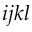<formula> <loc_0><loc_0><loc_500><loc_500>i j k l</formula> 